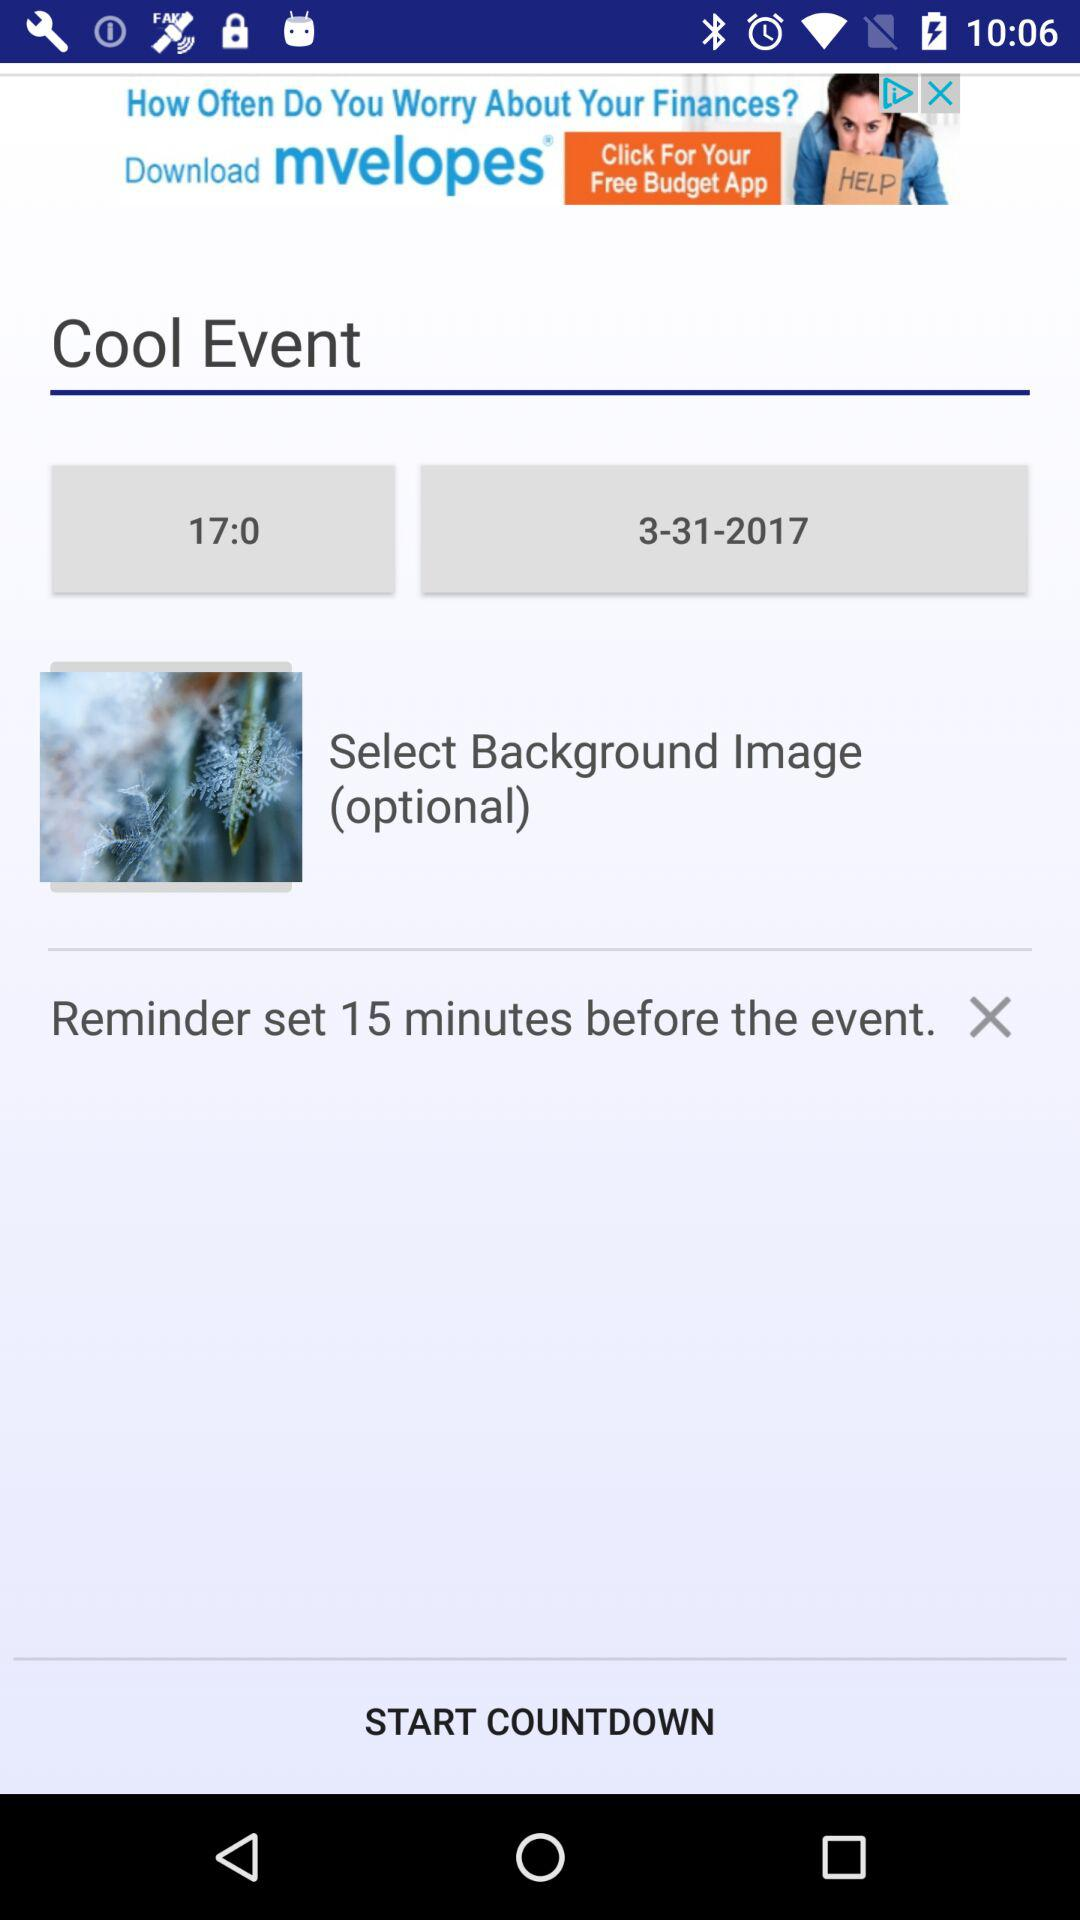How many minutes before the event is the reminder set? The reminder is set 15 minutes before the event. 